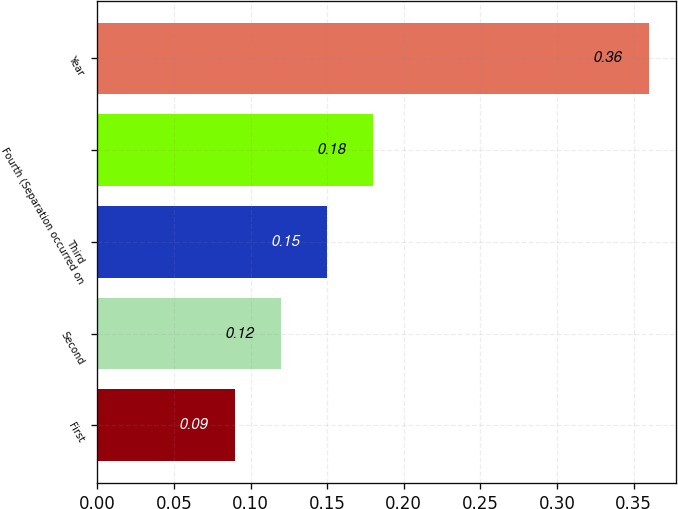<chart> <loc_0><loc_0><loc_500><loc_500><bar_chart><fcel>First<fcel>Second<fcel>Third<fcel>Fourth (Separation occurred on<fcel>Year<nl><fcel>0.09<fcel>0.12<fcel>0.15<fcel>0.18<fcel>0.36<nl></chart> 